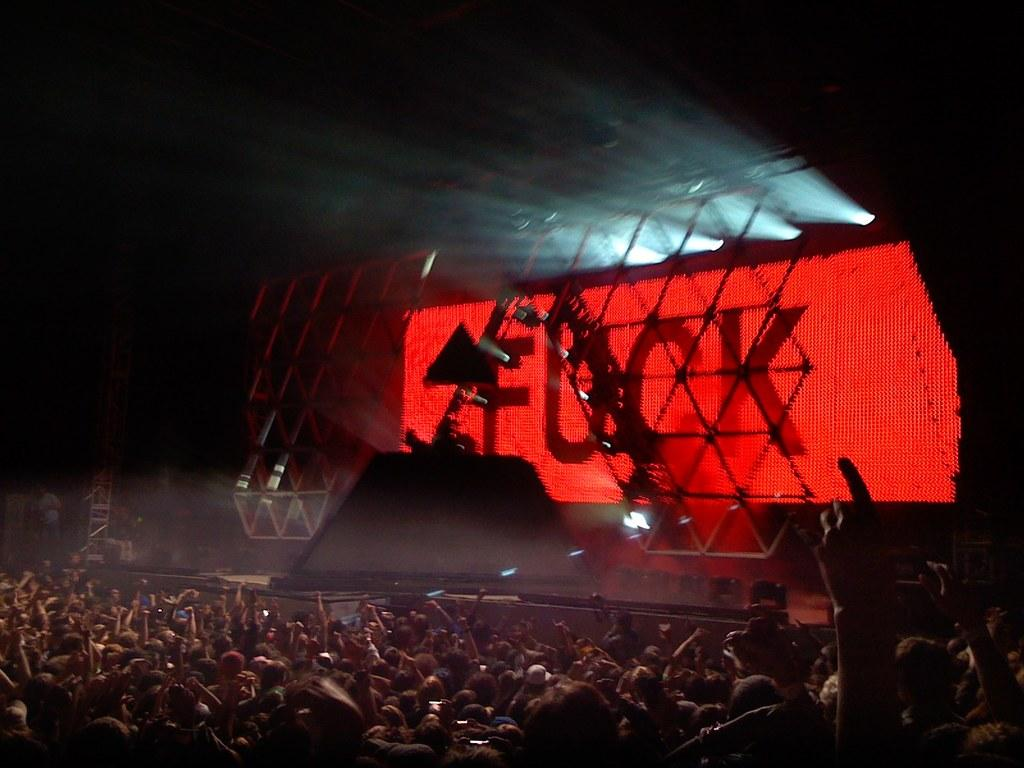Who is present in the image? There are people in the image. What are the people doing in the image? The people are watching a music concert. What type of fish can be seen swimming in the bag in the image? There is no fish or bag present in the image; the people are watching a music concert. 